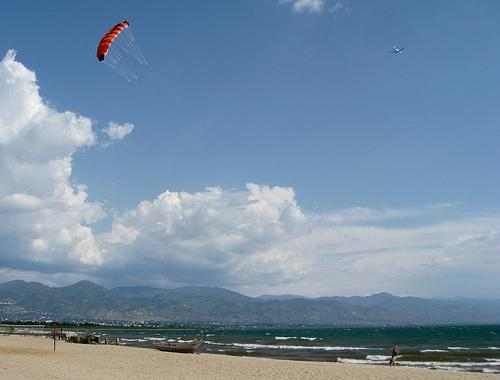Compose a haiku inspired by the image. Nature's symphony. Mention the primary elements in the image and their interaction. A man holding parachute strings is flying a red kite on a sandy beach with a large mountain range in the background, surrounded by puffy clouds and blue sky. Describe the interaction between the main subject of the image and their surroundings. The man, standing near the water, flies a kite against the breathtaking backdrop of a mountain range, while the puffy clouds and blue sky bring life to this vibrant scene. Using descriptive language, provide a caption for the overall scene in the image. Embraced by the vast blue sky, a man basks in the sunlit shore, commanding a red kite into flight, with mountains and white clouds forming a sublime backdrop. Mention the scene's significant elements and their location in the image. A man on the sandy beach is flying a red kite in the foreground, while a mountain range and puffy clouds dominate the background landscape. Write a one-sentence description of the setting in the image. The scenic image captures a man on a sandy beach flying a colorful kite, with a stunning background of mountains and puffy clouds. Provide a brief summary of the most noticeable objects in the image. Man with kite on beach, picturesque mountains, puffy clouds, and boat ashore. Provide a caption that focuses on the main subject and their action in the image. A man masterfully steering his red kite on a sun-kissed beach, dwarfed by majestic mountains. List at least five elements from the given image. Man flying kite, mountain range, puffy clouds, sandy beach, and boat on the shore. Write a concise overview of the scenery depicted in the image. Man on beach flying kite, mountain range and puffy clouds in the background, blue sky, and scattered objects like boats and a volleyball net. 